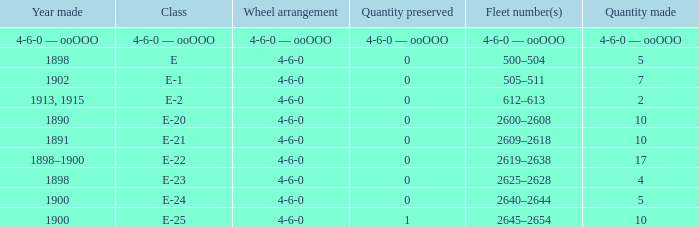What is the quantity preserved of the e-1 class? 0.0. 